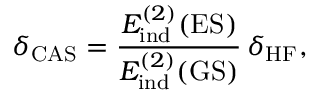Convert formula to latex. <formula><loc_0><loc_0><loc_500><loc_500>\delta _ { C A S } = \frac { E _ { i n d } ^ { ( 2 ) } ( E S ) } { E _ { i n d } ^ { ( 2 ) } ( G S ) } \, \delta _ { H F } ,</formula> 